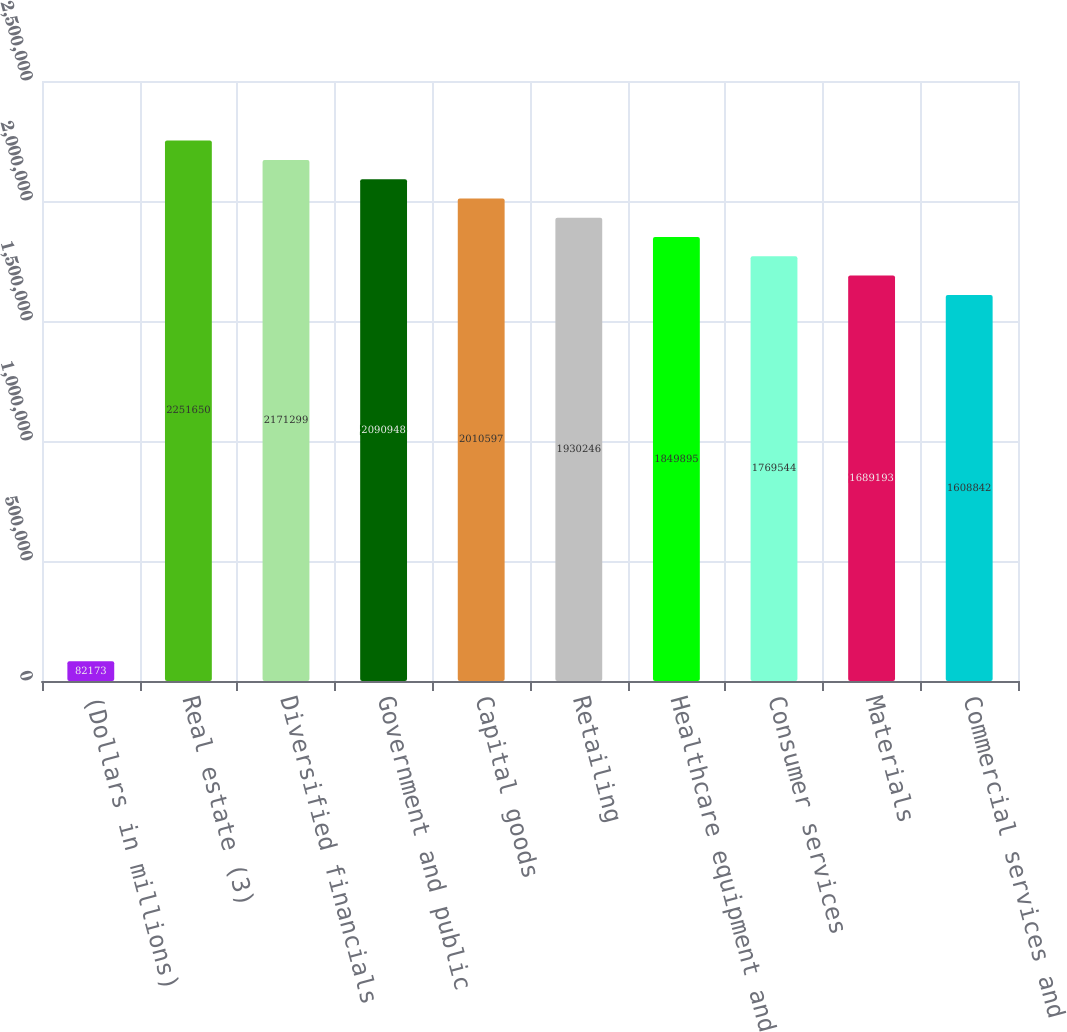<chart> <loc_0><loc_0><loc_500><loc_500><bar_chart><fcel>(Dollars in millions)<fcel>Real estate (3)<fcel>Diversified financials<fcel>Government and public<fcel>Capital goods<fcel>Retailing<fcel>Healthcare equipment and<fcel>Consumer services<fcel>Materials<fcel>Commercial services and<nl><fcel>82173<fcel>2.25165e+06<fcel>2.1713e+06<fcel>2.09095e+06<fcel>2.0106e+06<fcel>1.93025e+06<fcel>1.8499e+06<fcel>1.76954e+06<fcel>1.68919e+06<fcel>1.60884e+06<nl></chart> 